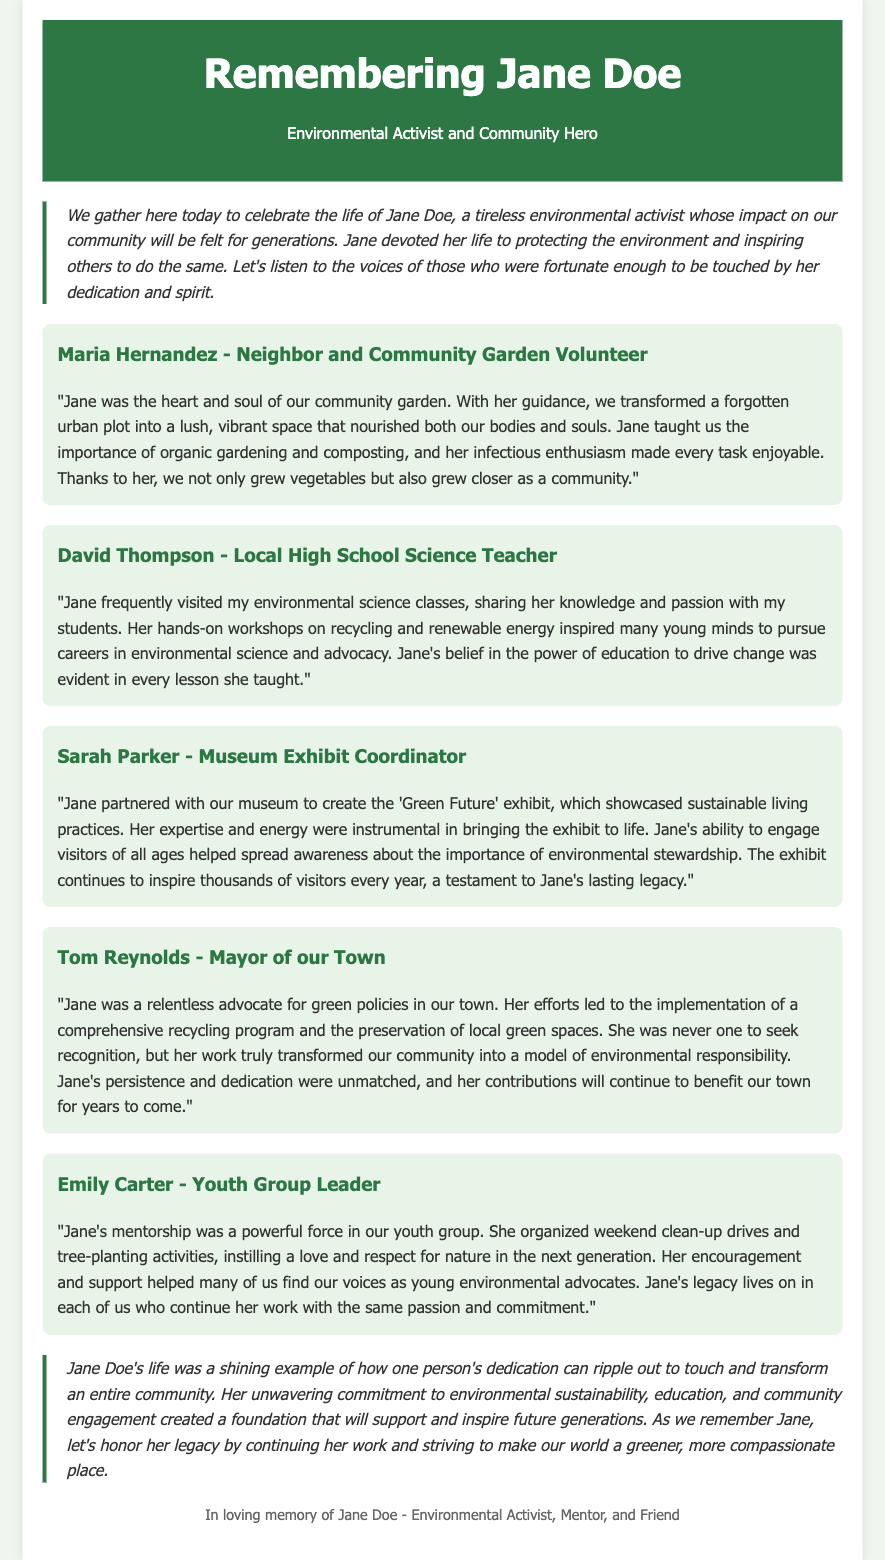what was Jane Doe's primary focus as an activist? The eulogy states that Jane devoted her life to protecting the environment and inspiring others.
Answer: protecting the environment who described Jane as the heart and soul of the community garden? Maria Hernandez refers to Jane in this manner in her testimony.
Answer: Maria Hernandez which exhibit did Jane partner with the museum to create? The eulogy mentions the 'Green Future' exhibit as a collaboration with the museum.
Answer: 'Green Future' who was inspired to pursue careers in environmental science due to Jane's workshops? David Thompson mentions that his students were inspired by Jane's workshops.
Answer: students what did Jane lead the effort to implement in the town? Tom Reynolds discusses Jane's efforts that led to implementing a comprehensive recycling program.
Answer: comprehensive recycling program how did Jane influence the youth group according to Emily Carter? Emily Carter states that Jane's mentorship instilled a love and respect for nature.
Answer: love and respect for nature who did Jane partner with to create an environmental exhibit? Sarah Parker notes that Jane collaborated with the museum for the exhibit.
Answer: museum how did Jane's contributions affect the future of the community? The conclusion states that her contributions will continue to benefit the community for years to come.
Answer: benefit our town for years to come 